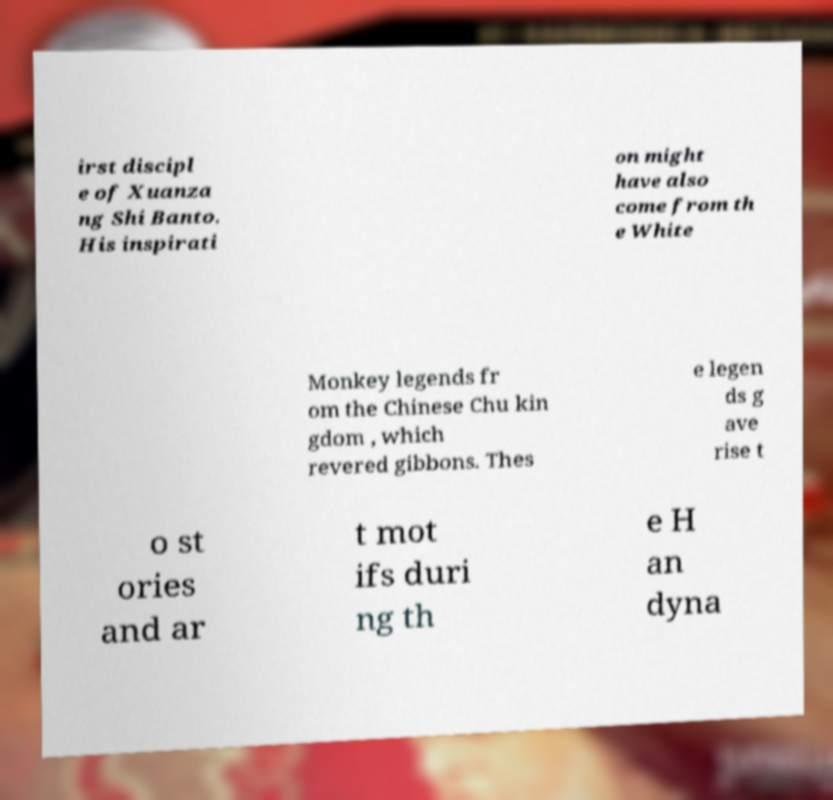I need the written content from this picture converted into text. Can you do that? irst discipl e of Xuanza ng Shi Banto. His inspirati on might have also come from th e White Monkey legends fr om the Chinese Chu kin gdom , which revered gibbons. Thes e legen ds g ave rise t o st ories and ar t mot ifs duri ng th e H an dyna 